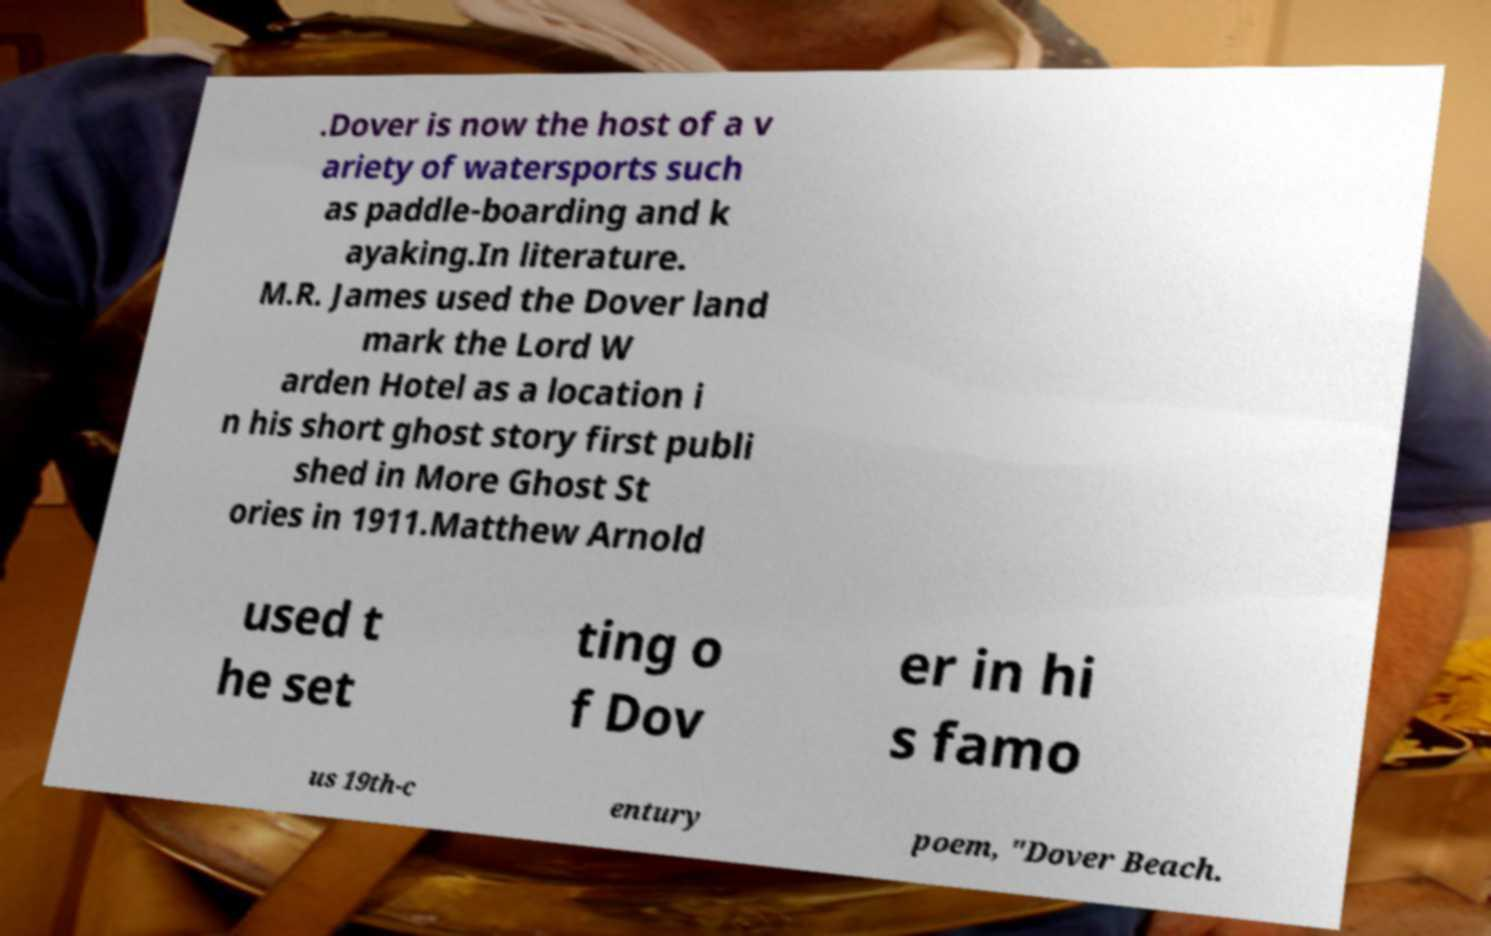There's text embedded in this image that I need extracted. Can you transcribe it verbatim? .Dover is now the host of a v ariety of watersports such as paddle-boarding and k ayaking.In literature. M.R. James used the Dover land mark the Lord W arden Hotel as a location i n his short ghost story first publi shed in More Ghost St ories in 1911.Matthew Arnold used t he set ting o f Dov er in hi s famo us 19th-c entury poem, "Dover Beach. 